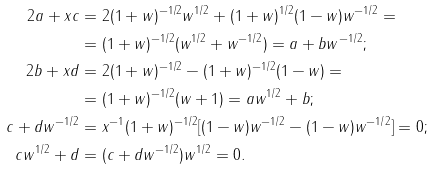<formula> <loc_0><loc_0><loc_500><loc_500>2 a + x c & = 2 ( 1 + w ) ^ { - 1 / 2 } w ^ { 1 / 2 } + ( 1 + w ) ^ { 1 / 2 } ( 1 - w ) w ^ { - 1 / 2 } = \\ & = ( 1 + w ) ^ { - 1 / 2 } ( w ^ { 1 / 2 } + w ^ { - 1 / 2 } ) = a + b w ^ { - 1 / 2 } ; \\ 2 b + x d & = 2 ( 1 + w ) ^ { - 1 / 2 } - ( 1 + w ) ^ { - 1 / 2 } ( 1 - w ) = \\ & = ( 1 + w ) ^ { - 1 / 2 } ( w + 1 ) = a w ^ { 1 / 2 } + b ; \\ c + d w ^ { - 1 / 2 } & = x ^ { - 1 } ( 1 + w ) ^ { - 1 / 2 } [ ( 1 - w ) w ^ { - 1 / 2 } - ( 1 - w ) w ^ { - 1 / 2 } ] = 0 ; \\ c w ^ { 1 / 2 } + d & = ( c + d w ^ { - 1 / 2 } ) w ^ { 1 / 2 } = 0 .</formula> 